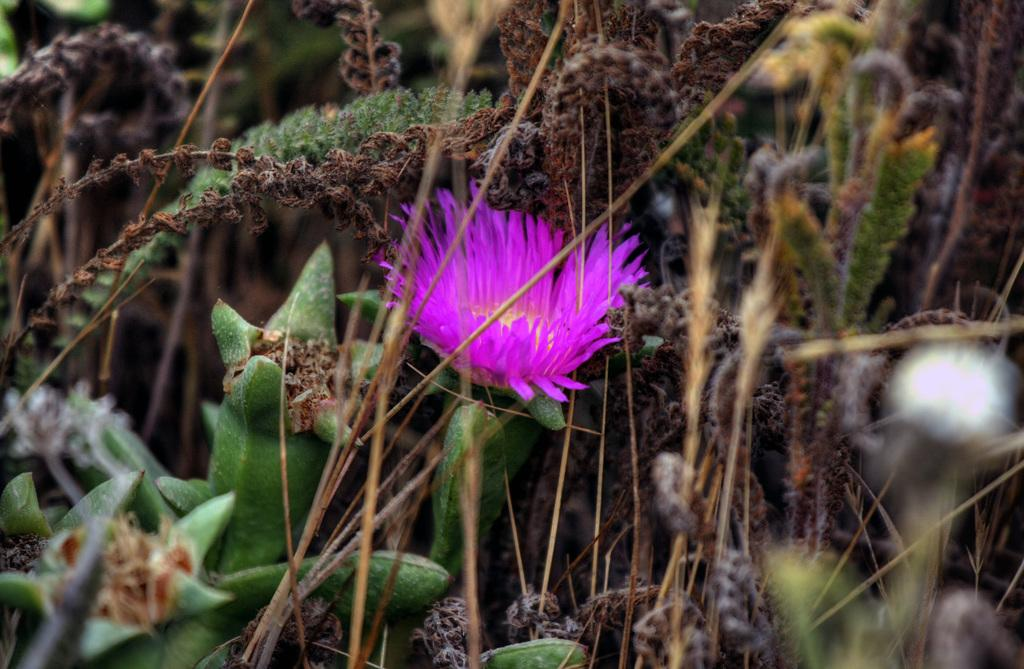What type of flower is present in the image? There is a pink flower in the image. What else can be seen in the image besides the flower? There are branches of plants in the image. What type of wound can be seen on the linen in the image? There is no linen or wound present in the image; it only features a pink flower and branches of plants. 